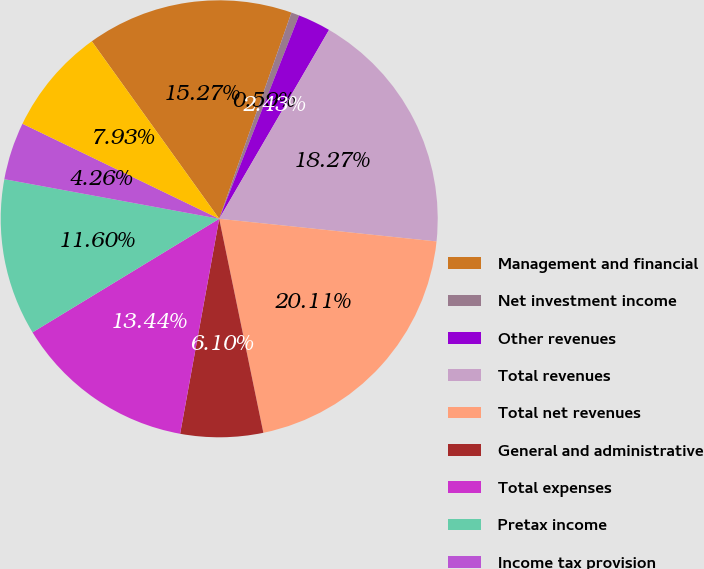Convert chart. <chart><loc_0><loc_0><loc_500><loc_500><pie_chart><fcel>Management and financial<fcel>Net investment income<fcel>Other revenues<fcel>Total revenues<fcel>Total net revenues<fcel>General and administrative<fcel>Total expenses<fcel>Pretax income<fcel>Income tax provision<fcel>Net income<nl><fcel>15.27%<fcel>0.59%<fcel>2.43%<fcel>18.27%<fcel>20.11%<fcel>6.1%<fcel>13.44%<fcel>11.6%<fcel>4.26%<fcel>7.93%<nl></chart> 